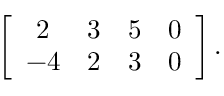Convert formula to latex. <formula><loc_0><loc_0><loc_500><loc_500>\left [ { \begin{array} { c c c c } { 2 } & { 3 } & { 5 } & { 0 } \\ { - 4 } & { 2 } & { 3 } & { 0 } \end{array} } \right ] .</formula> 